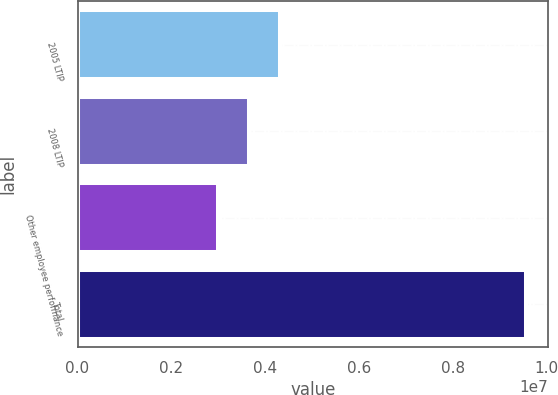<chart> <loc_0><loc_0><loc_500><loc_500><bar_chart><fcel>2005 LTIP<fcel>2008 LTIP<fcel>Other employee performance<fcel>Total<nl><fcel>4.30988e+06<fcel>3.65494e+06<fcel>3e+06<fcel>9.54938e+06<nl></chart> 